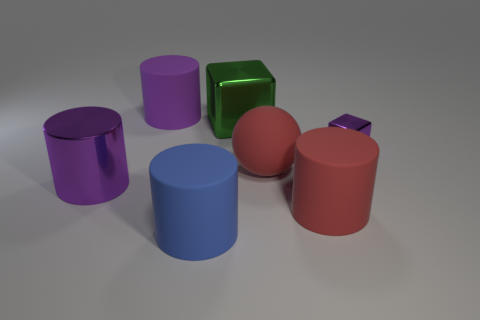Is there a red matte cylinder that has the same size as the green shiny cube?
Make the answer very short. Yes. Is the number of large blocks less than the number of red things?
Your answer should be very brief. Yes. The thing that is on the right side of the large matte cylinder on the right side of the blue rubber object in front of the green thing is what shape?
Offer a very short reply. Cube. How many objects are large metallic blocks that are behind the red ball or matte cylinders on the left side of the big block?
Provide a succinct answer. 3. There is a red ball; are there any tiny purple cubes behind it?
Your response must be concise. Yes. How many objects are cubes that are in front of the big green thing or large blue rubber things?
Keep it short and to the point. 2. How many green objects are large matte cylinders or metallic objects?
Your response must be concise. 1. What number of other objects are there of the same color as the large shiny cylinder?
Provide a short and direct response. 2. Is the number of shiny things on the left side of the green metal thing less than the number of red matte things?
Give a very brief answer. Yes. There is a big cylinder on the right side of the large cylinder that is in front of the rubber thing on the right side of the large red rubber ball; what color is it?
Offer a terse response. Red. 